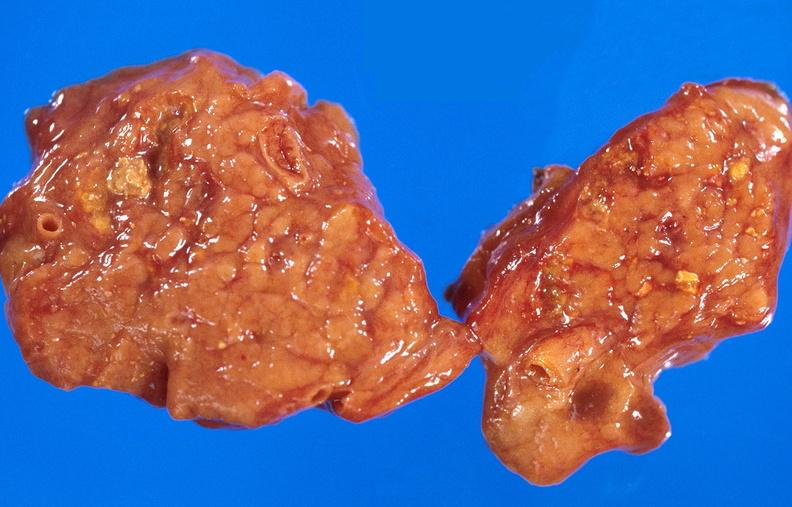what does this image show?
Answer the question using a single word or phrase. Pancreatic fat necrosis 